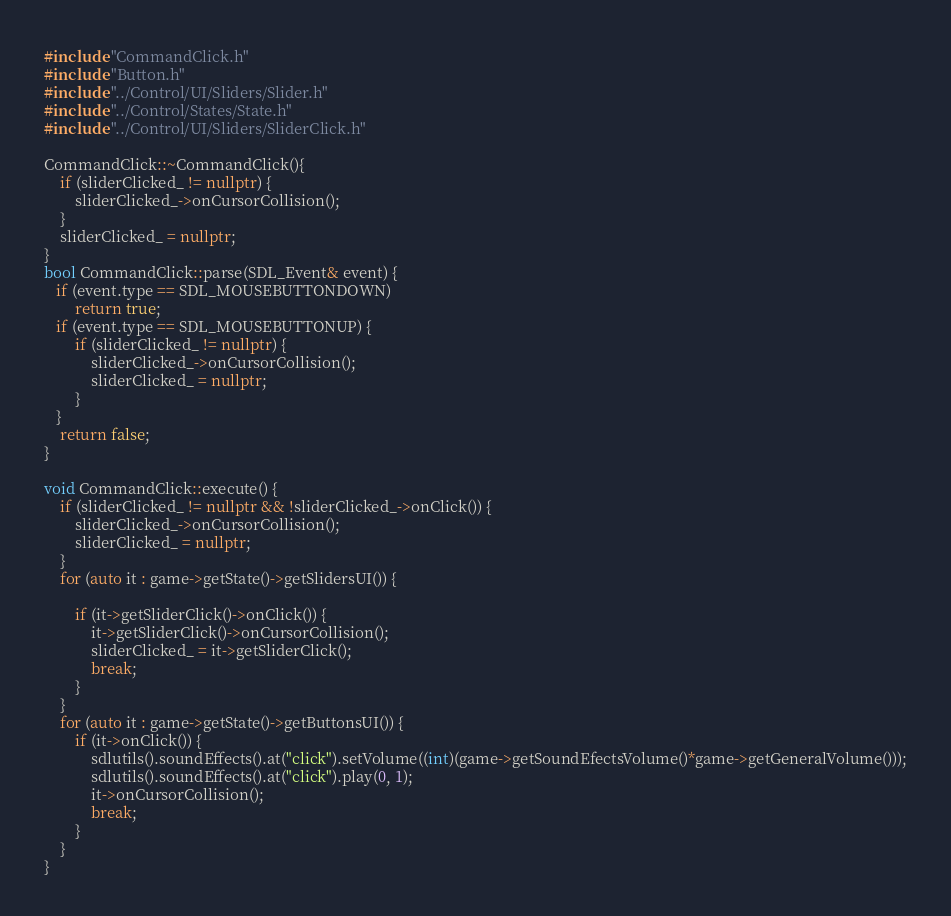Convert code to text. <code><loc_0><loc_0><loc_500><loc_500><_C++_>#include "CommandClick.h"
#include "Button.h"
#include "../Control/UI/Sliders/Slider.h"
#include "../Control/States/State.h"
#include "../Control/UI/Sliders/SliderClick.h"

CommandClick::~CommandClick(){
    if (sliderClicked_ != nullptr) {
        sliderClicked_->onCursorCollision();
    }
    sliderClicked_ = nullptr;
}
bool CommandClick::parse(SDL_Event& event) {
   if (event.type == SDL_MOUSEBUTTONDOWN)     
        return true;
   if (event.type == SDL_MOUSEBUTTONUP) {      
        if (sliderClicked_ != nullptr) { 
            sliderClicked_->onCursorCollision(); 
            sliderClicked_ = nullptr; 
        }
   }
    return false;
}

void CommandClick::execute() {
    if (sliderClicked_ != nullptr && !sliderClicked_->onClick()) {
        sliderClicked_->onCursorCollision();
        sliderClicked_ = nullptr;
    }
    for (auto it : game->getState()->getSlidersUI()) {

        if (it->getSliderClick()->onClick()) {
            it->getSliderClick()->onCursorCollision();
            sliderClicked_ = it->getSliderClick();
            break;
        }
    } 
    for (auto it : game->getState()->getButtonsUI()) {
        if (it->onClick()) {
            sdlutils().soundEffects().at("click").setVolume((int)(game->getSoundEfectsVolume()*game->getGeneralVolume()));
            sdlutils().soundEffects().at("click").play(0, 1);
            it->onCursorCollision();
            break;
        }
    }
}</code> 